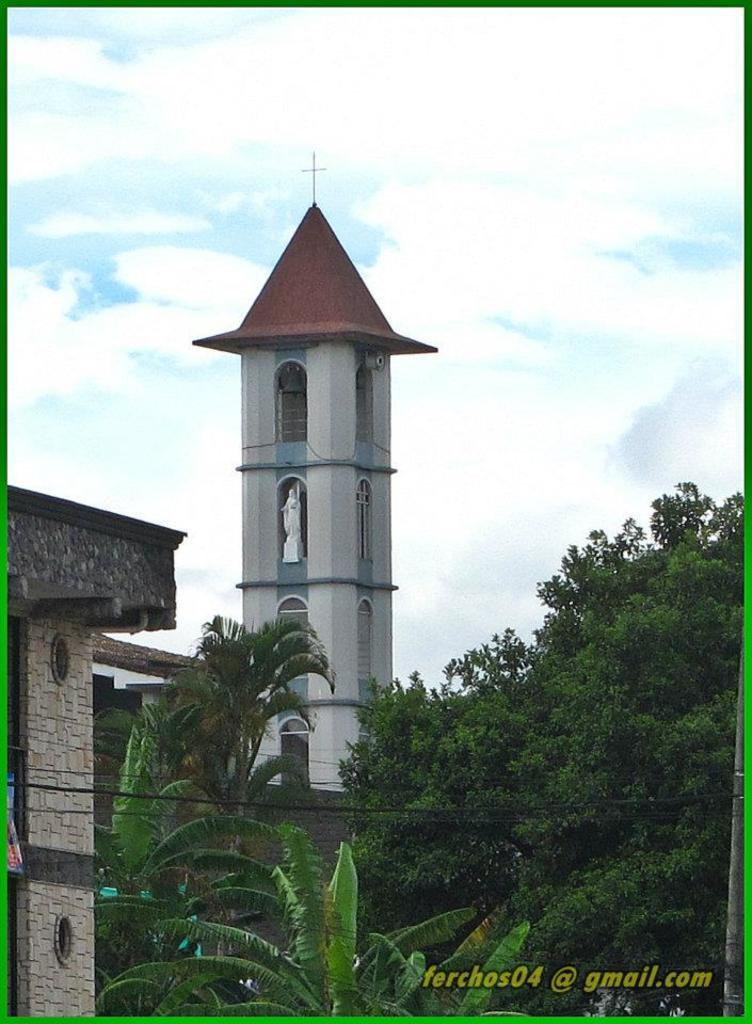How would you summarize this image in a sentence or two? This picture shows buildings and we see trees and we see a blue cloudy sky and we see text at the bottom right corner. 